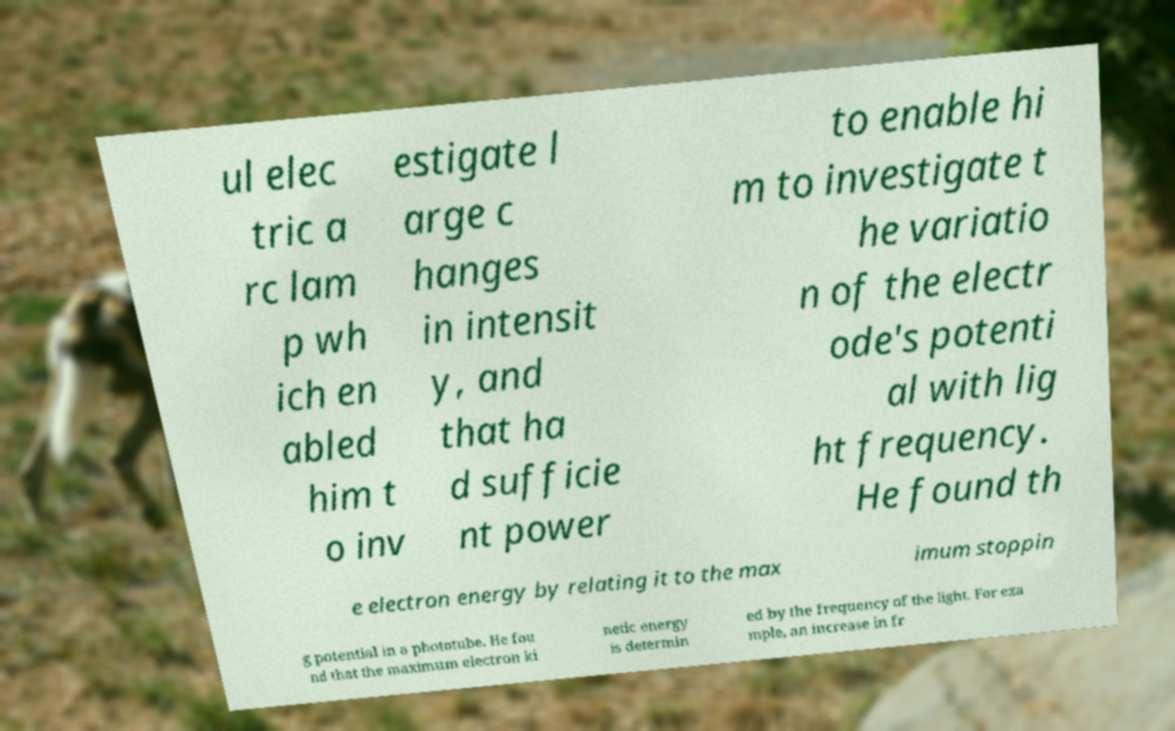Can you accurately transcribe the text from the provided image for me? ul elec tric a rc lam p wh ich en abled him t o inv estigate l arge c hanges in intensit y, and that ha d sufficie nt power to enable hi m to investigate t he variatio n of the electr ode's potenti al with lig ht frequency. He found th e electron energy by relating it to the max imum stoppin g potential in a phototube. He fou nd that the maximum electron ki netic energy is determin ed by the frequency of the light. For exa mple, an increase in fr 